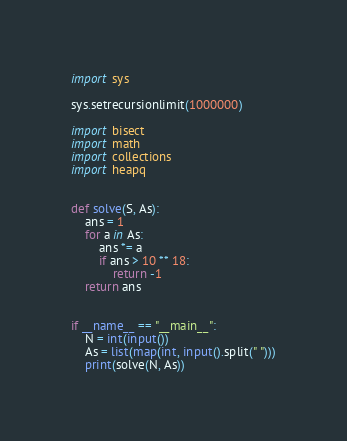<code> <loc_0><loc_0><loc_500><loc_500><_Python_>import sys

sys.setrecursionlimit(1000000)

import bisect
import math
import collections
import heapq


def solve(S, As):
    ans = 1
    for a in As:
        ans *= a
        if ans > 10 ** 18:
            return -1
    return ans


if __name__ == "__main__":
    N = int(input())
    As = list(map(int, input().split(" ")))
    print(solve(N, As))
</code> 